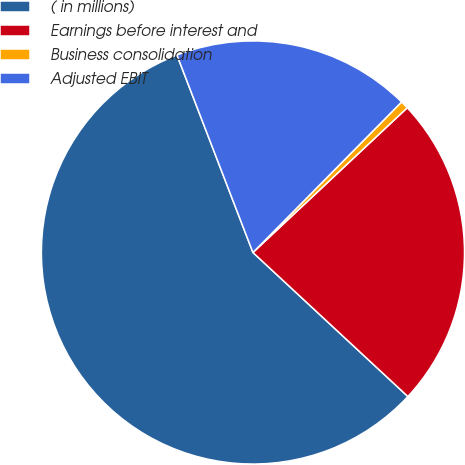<chart> <loc_0><loc_0><loc_500><loc_500><pie_chart><fcel>( in millions)<fcel>Earnings before interest and<fcel>Business consolidation<fcel>Adjusted EBIT<nl><fcel>57.24%<fcel>23.91%<fcel>0.61%<fcel>18.25%<nl></chart> 